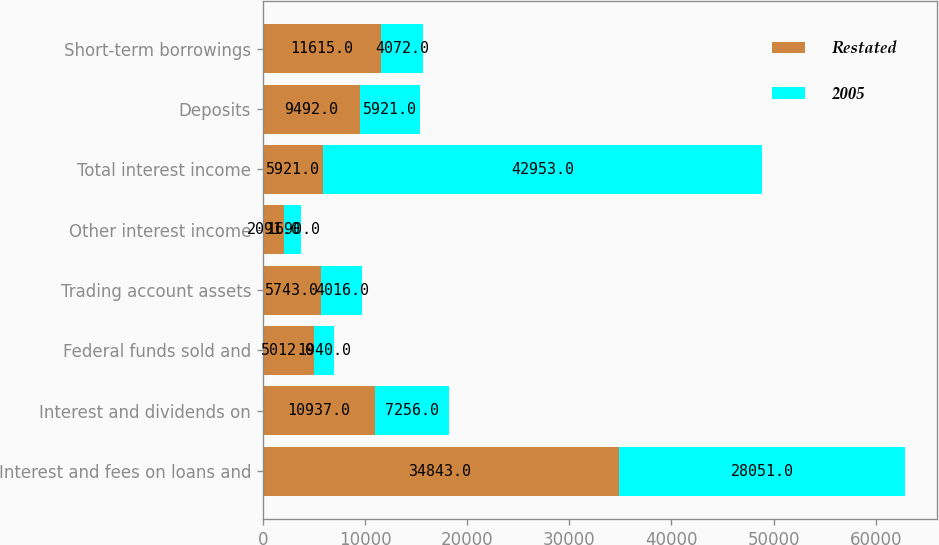Convert chart to OTSL. <chart><loc_0><loc_0><loc_500><loc_500><stacked_bar_chart><ecel><fcel>Interest and fees on loans and<fcel>Interest and dividends on<fcel>Federal funds sold and<fcel>Trading account assets<fcel>Other interest income<fcel>Total interest income<fcel>Deposits<fcel>Short-term borrowings<nl><fcel>Restated<fcel>34843<fcel>10937<fcel>5012<fcel>5743<fcel>2091<fcel>5921<fcel>9492<fcel>11615<nl><fcel>2005<fcel>28051<fcel>7256<fcel>1940<fcel>4016<fcel>1690<fcel>42953<fcel>5921<fcel>4072<nl></chart> 